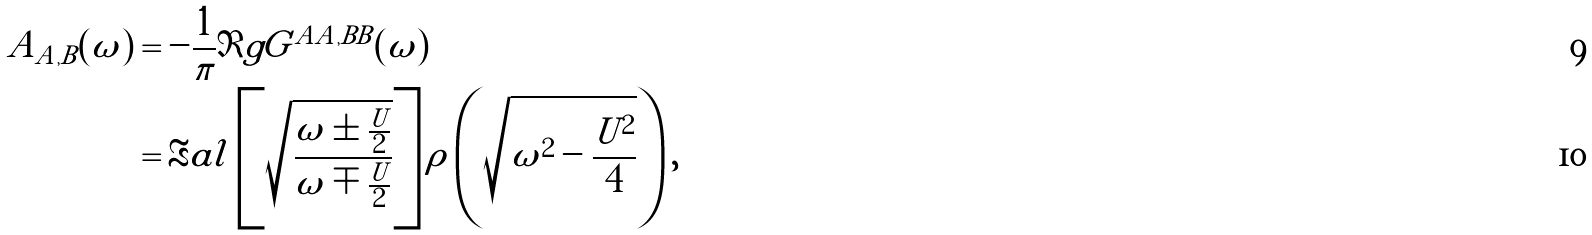<formula> <loc_0><loc_0><loc_500><loc_500>A _ { A , B } ( \omega ) & = - \frac { 1 } { \pi } \Im g G ^ { A A , B B } ( \omega ) \\ & = \Re a l \left [ \sqrt { \frac { \omega \pm \frac { U } { 2 } } { \omega \mp \frac { U } { 2 } } } \right ] \rho \left ( \sqrt { \omega ^ { 2 } - \frac { U ^ { 2 } } { 4 } } \right ) ,</formula> 